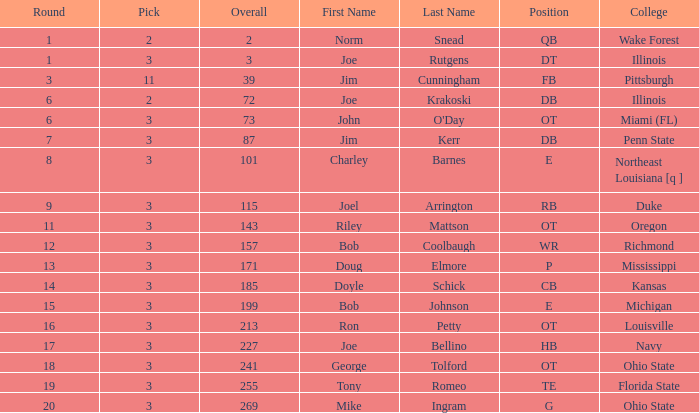How many rounds have john o'day as the name, and a pick less than 3? None. 